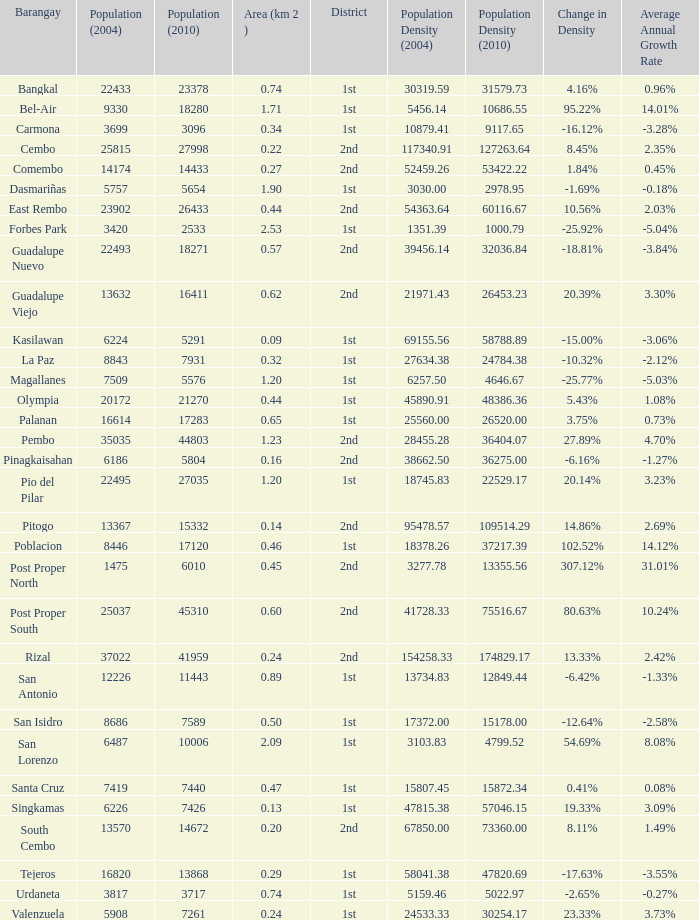What is the area where barangay is guadalupe viejo? 0.62. 